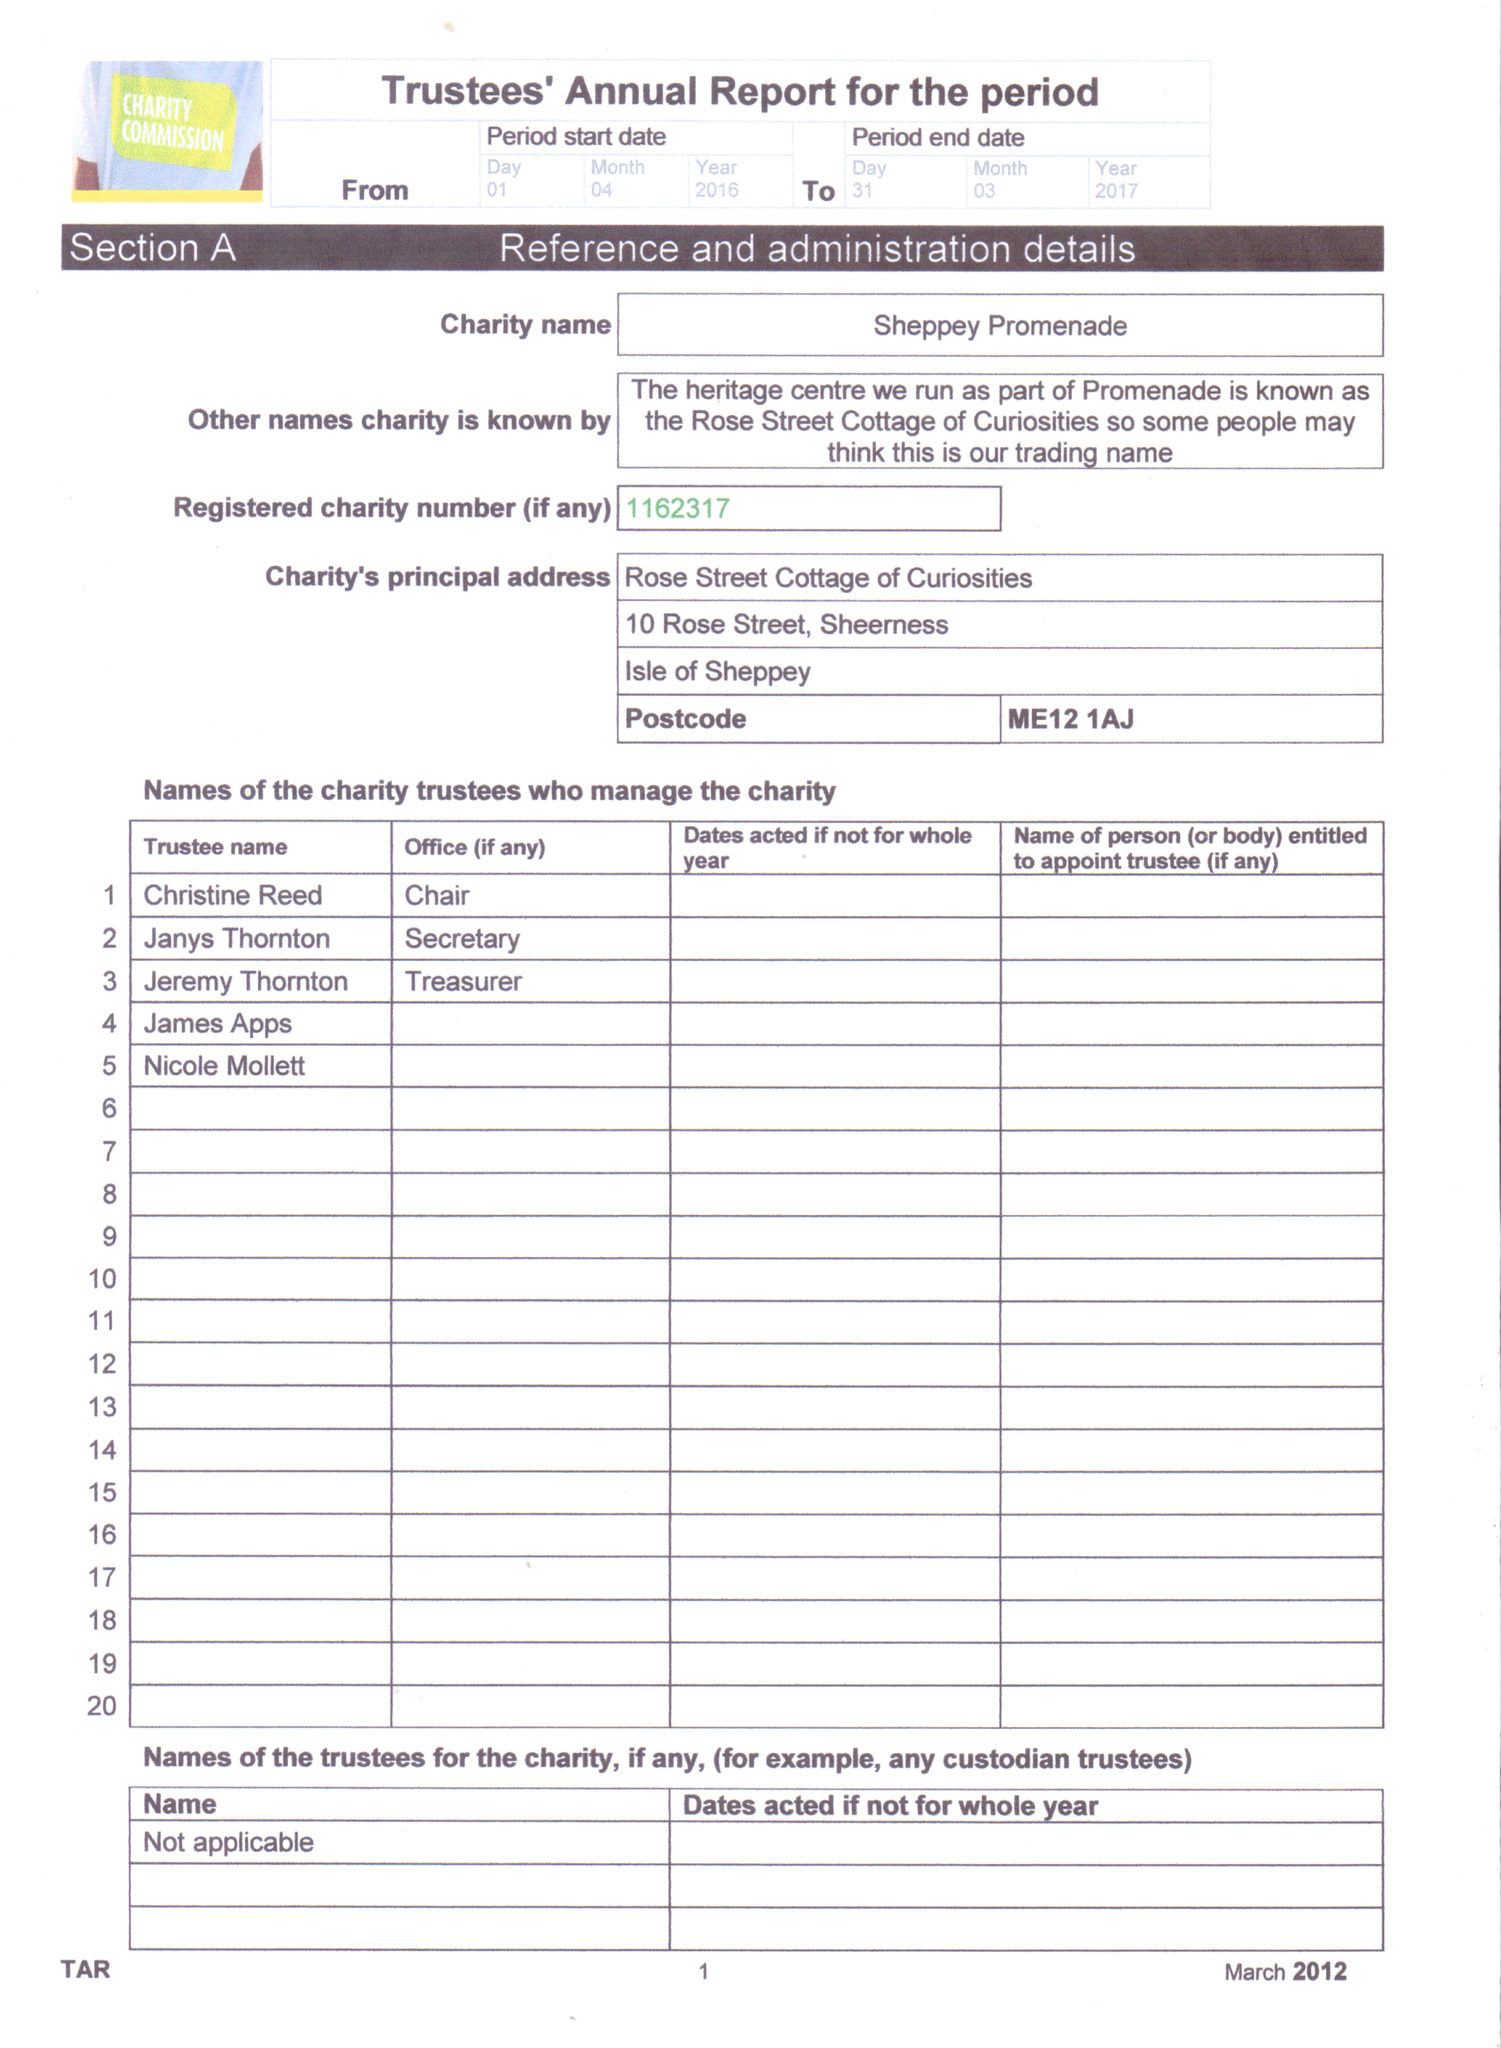What is the value for the address__postcode?
Answer the question using a single word or phrase. ME12 1AJ 